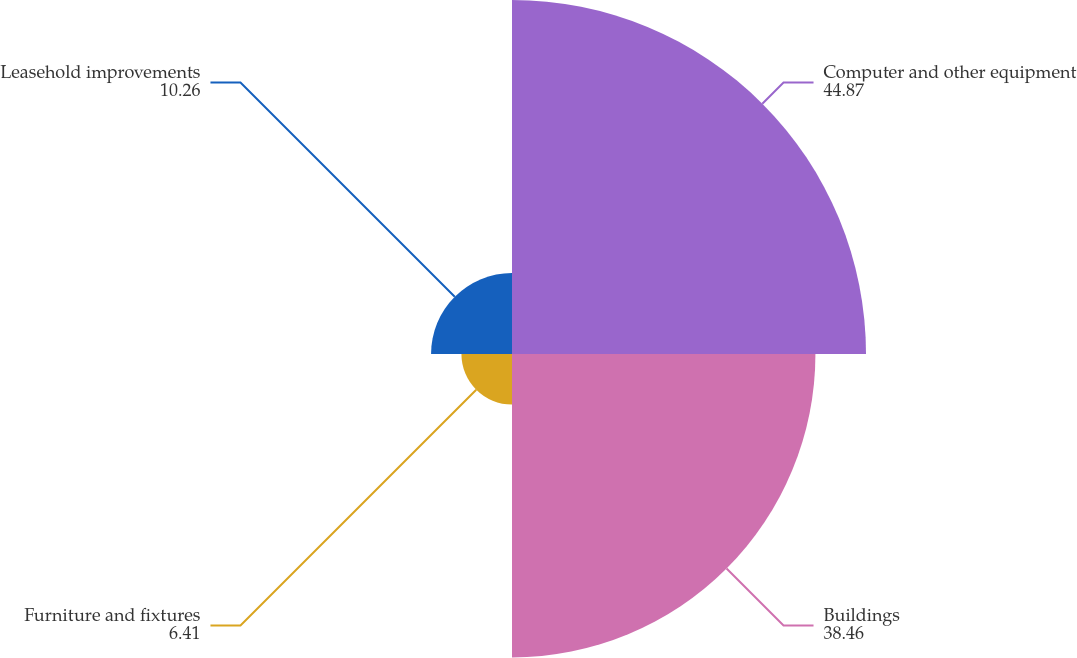<chart> <loc_0><loc_0><loc_500><loc_500><pie_chart><fcel>Computer and other equipment<fcel>Buildings<fcel>Furniture and fixtures<fcel>Leasehold improvements<nl><fcel>44.87%<fcel>38.46%<fcel>6.41%<fcel>10.26%<nl></chart> 